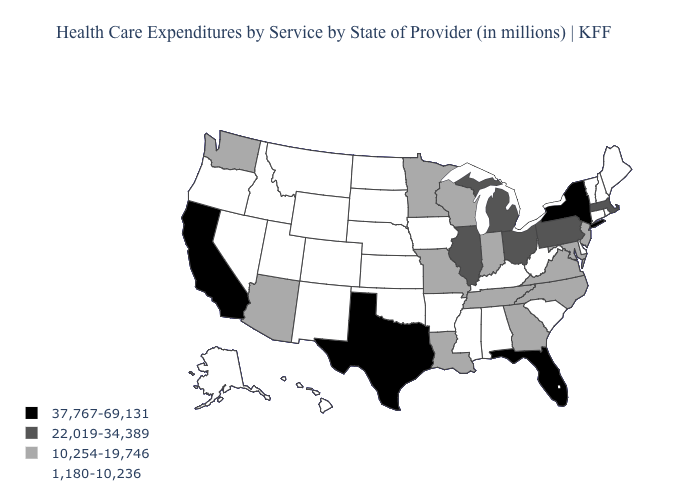What is the value of Nebraska?
Keep it brief. 1,180-10,236. Which states hav the highest value in the MidWest?
Be succinct. Illinois, Michigan, Ohio. Name the states that have a value in the range 22,019-34,389?
Concise answer only. Illinois, Massachusetts, Michigan, Ohio, Pennsylvania. Which states have the lowest value in the MidWest?
Short answer required. Iowa, Kansas, Nebraska, North Dakota, South Dakota. Does the first symbol in the legend represent the smallest category?
Keep it brief. No. What is the value of Nebraska?
Be succinct. 1,180-10,236. Does Maine have the same value as California?
Write a very short answer. No. Does the first symbol in the legend represent the smallest category?
Be succinct. No. Does Pennsylvania have a higher value than Kentucky?
Keep it brief. Yes. What is the value of Kansas?
Short answer required. 1,180-10,236. Does Alabama have the same value as Montana?
Concise answer only. Yes. Which states have the highest value in the USA?
Short answer required. California, Florida, New York, Texas. Name the states that have a value in the range 1,180-10,236?
Give a very brief answer. Alabama, Alaska, Arkansas, Colorado, Connecticut, Delaware, Hawaii, Idaho, Iowa, Kansas, Kentucky, Maine, Mississippi, Montana, Nebraska, Nevada, New Hampshire, New Mexico, North Dakota, Oklahoma, Oregon, Rhode Island, South Carolina, South Dakota, Utah, Vermont, West Virginia, Wyoming. What is the value of North Dakota?
Concise answer only. 1,180-10,236. Name the states that have a value in the range 1,180-10,236?
Quick response, please. Alabama, Alaska, Arkansas, Colorado, Connecticut, Delaware, Hawaii, Idaho, Iowa, Kansas, Kentucky, Maine, Mississippi, Montana, Nebraska, Nevada, New Hampshire, New Mexico, North Dakota, Oklahoma, Oregon, Rhode Island, South Carolina, South Dakota, Utah, Vermont, West Virginia, Wyoming. 